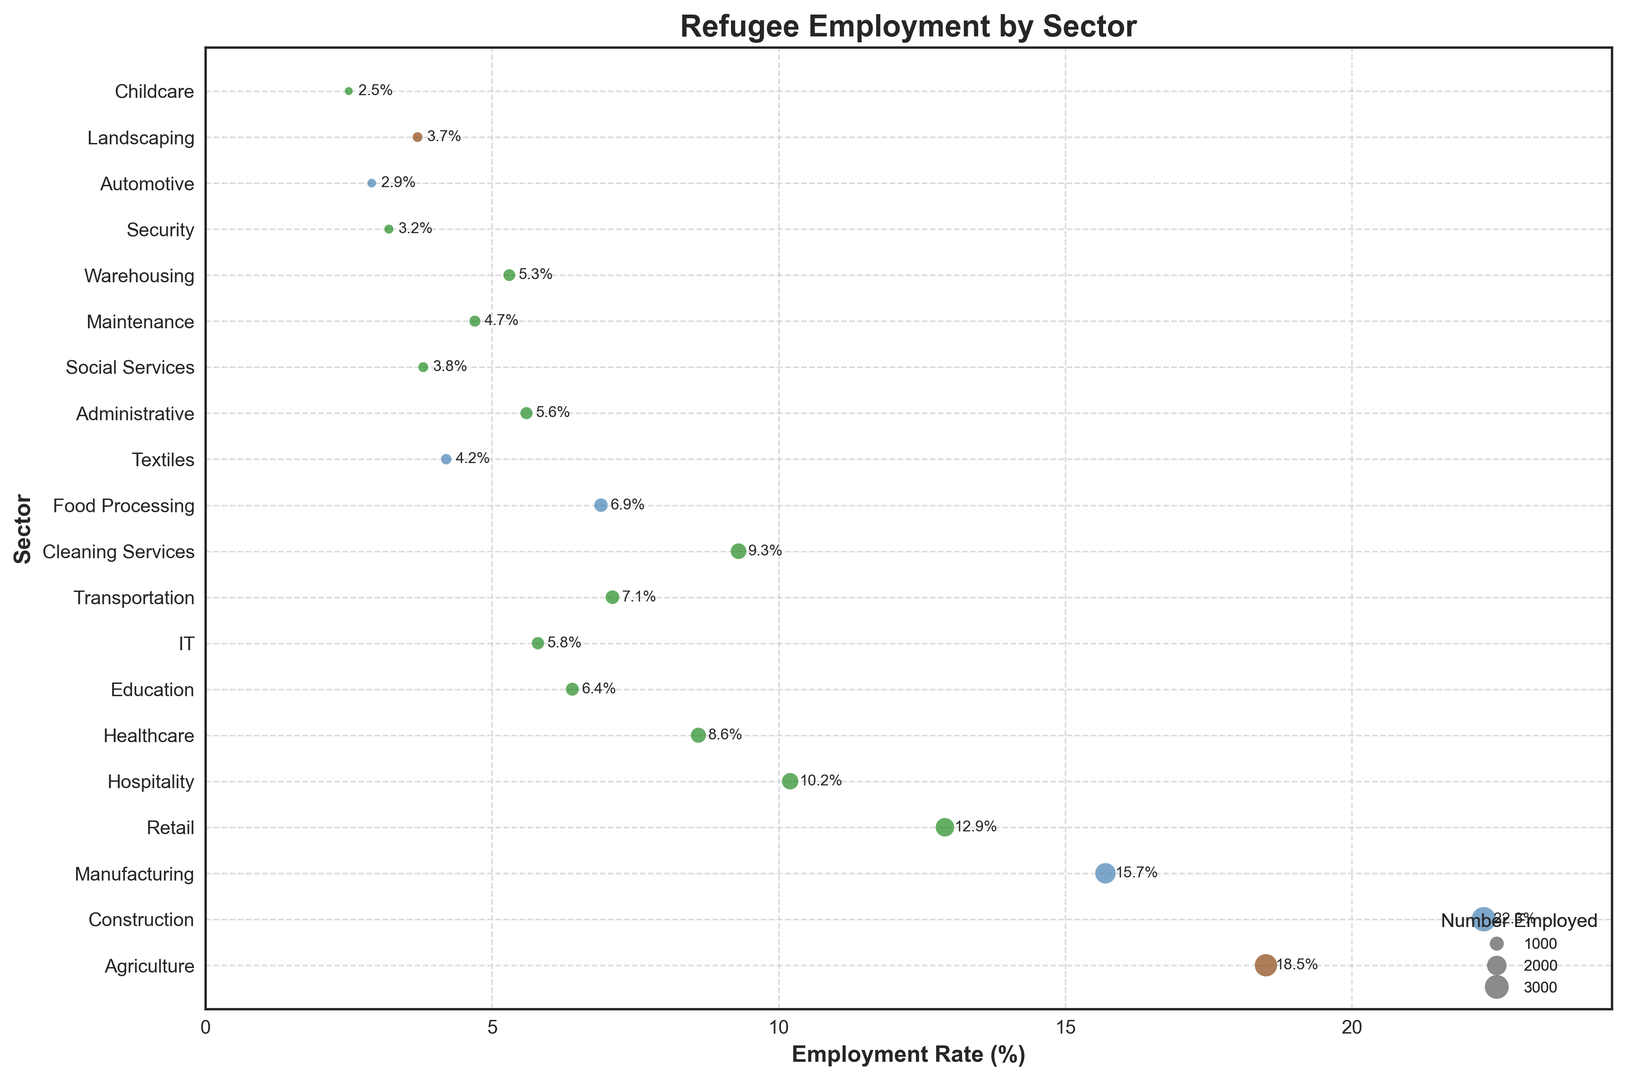Which sector has the highest employment rate among refugees? From the chart, we can observe that the sector with the highest employment rate among refugees is shown at the far-right end in terms of the x-axis. "Construction" has the furthest x-coordinate value (22.3%).
Answer: Construction Which industry type appears most frequently in the chart? Visual inspection shows that the most frequent color in the bubbles is green, which represents the "Tertiary" industry type in the legend.
Answer: Tertiary How does the employment rate of Agriculture compare to that of Healthcare? By examining the chart, Agriculture has an employment rate of 18.5%, while Healthcare has an employment rate of 8.6%. Therefore, Agriculture's employment rate is higher.
Answer: Agriculture's rate is higher What is the total number of employed individuals in the Tertiary industry type? Sum the number of employed individuals for sectors labeled as "Tertiary": \[1980 (Retail) + 1560 (Hospitality) + 1320 (Healthcare) + 980 (Education) + 890 (IT) + 1090 (Transportation) + 1425 (Cleaning Services) + 860 (Administrative) + 585 (Social Services) + 720 (Maintenance) + 815 (Warehousing) + 490 (Security) + 570 (Landscaping) + 385 (Childcare) = 13670\]
Answer: 13670 Which sector is represented with the smallest bubble, and what does it indicate? The smallest bubble (smallest area on the chart) corresponds to the "Childcare" sector. This indicates that the childcare sector has the lowest number of employed individuals (385).
Answer: Childcare How does the employment rate in the Primary industry type compare to the overall median employment rate? The Primary industry consists of Agriculture (18.5%) and Landscaping (3.7%). The overall employment rates are \[18.5, 22.3, 15.7, 12.9, 10.2, 8.6, 6.4, 5.8, 7.1, 9.3, 6.9, 4.2, 5.6, 3.8, 4.7, 5.3, 3.2, 2.9, 3.7, 2.5\]. Sorting these gives \[2.5, 2.9, 3.2, 3.7, 3.8, 4.2, 4.7, 5.3, 5.6, 5.8, 6.4, 6.9, 7.1, 8.6, 9.3, 10.2, 12.9, 15.7, 18.5, 22.3\], so the median is between 5.8 and 6.4, i.e., (5.8+6.4)/2 = 6.1%. Comparing the Primary industry (11.1/2=9.1%) shows the Primary industry has a higher average rate.
Answer: Higher for Primary (9.1% vs. 6.1%) What sector has the highest number of employed individuals and what is its employment rate? The largest bubble is observed for the "Construction" sector, which means it has the highest number of employed individuals (3400). Its employment rate is 22.3%.
Answer: Construction (22.3%) Compare the employment rates of Manufacturing and Textiles. Referring to the chart, Manufacturing has an employment rate of 15.7%, while Textiles has an employment rate of 4.2%.
Answer: Manufacturing has a higher rate Which sector in the Secondary industry type has the lowest employment rate? In the Secondary industry type, the chart displays several sectors including Construction, Manufacturing, Food Processing, Textiles, Automotive. Among them, "Automotive" has the lowest employment rate at 2.9%.
Answer: Automotive 